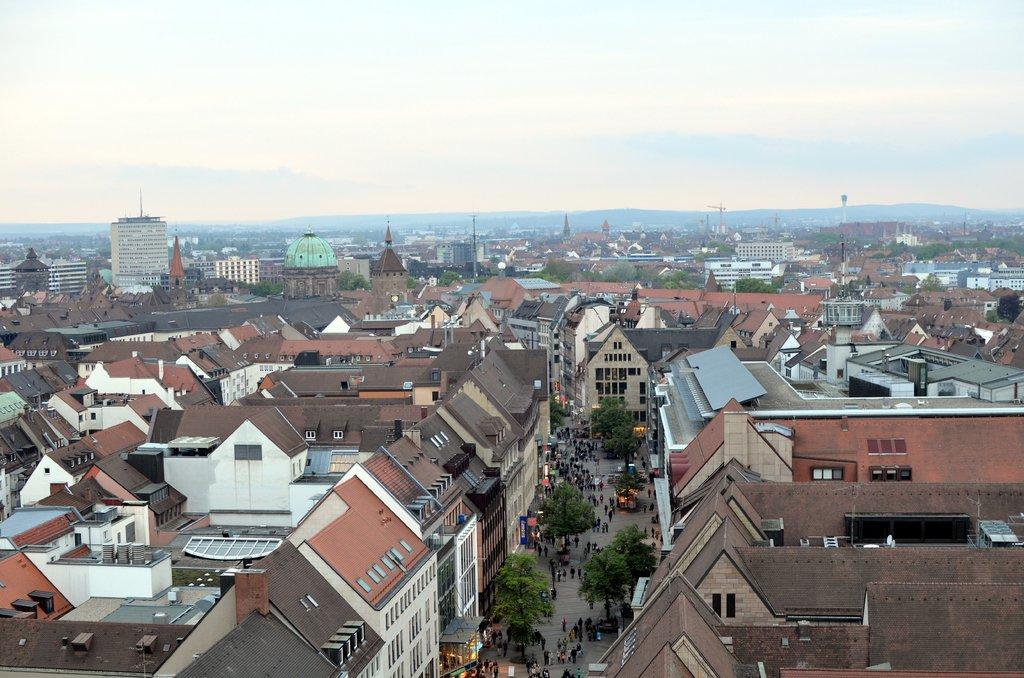Please provide a concise description of this image. In this picture I can see few buildings and I can see trees and few people walking and I can see a cloudy sky and few towers. 